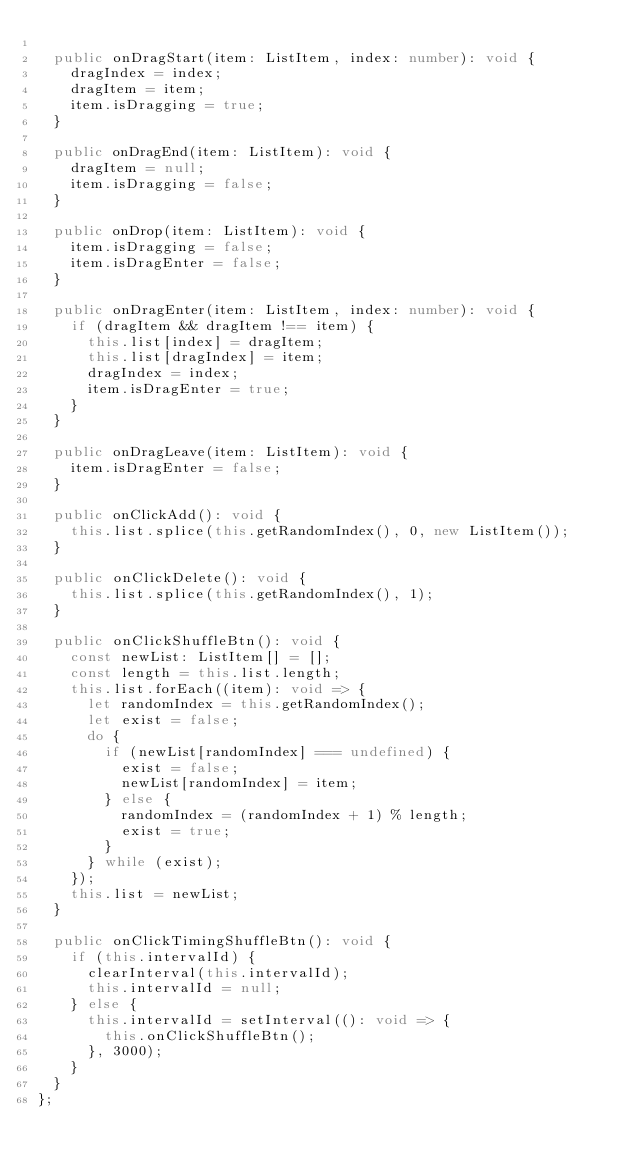<code> <loc_0><loc_0><loc_500><loc_500><_TypeScript_>
  public onDragStart(item: ListItem, index: number): void {
    dragIndex = index;
    dragItem = item;
    item.isDragging = true;
  }

  public onDragEnd(item: ListItem): void {
    dragItem = null;
    item.isDragging = false;
  }

  public onDrop(item: ListItem): void {
    item.isDragging = false;
    item.isDragEnter = false;
  }

  public onDragEnter(item: ListItem, index: number): void {
    if (dragItem && dragItem !== item) {
      this.list[index] = dragItem;
      this.list[dragIndex] = item;
      dragIndex = index;
      item.isDragEnter = true;
    }
  }

  public onDragLeave(item: ListItem): void {
    item.isDragEnter = false;
  }

  public onClickAdd(): void {
    this.list.splice(this.getRandomIndex(), 0, new ListItem());
  }

  public onClickDelete(): void {
    this.list.splice(this.getRandomIndex(), 1);
  }

  public onClickShuffleBtn(): void {
    const newList: ListItem[] = [];
    const length = this.list.length;
    this.list.forEach((item): void => {
      let randomIndex = this.getRandomIndex();
      let exist = false;
      do {
        if (newList[randomIndex] === undefined) {
          exist = false;
          newList[randomIndex] = item;
        } else {
          randomIndex = (randomIndex + 1) % length;
          exist = true;
        }
      } while (exist);
    });
    this.list = newList;
  }

  public onClickTimingShuffleBtn(): void {
    if (this.intervalId) {
      clearInterval(this.intervalId);
      this.intervalId = null;
    } else {
      this.intervalId = setInterval((): void => {
        this.onClickShuffleBtn();
      }, 3000);
    }
  }
};
</code> 